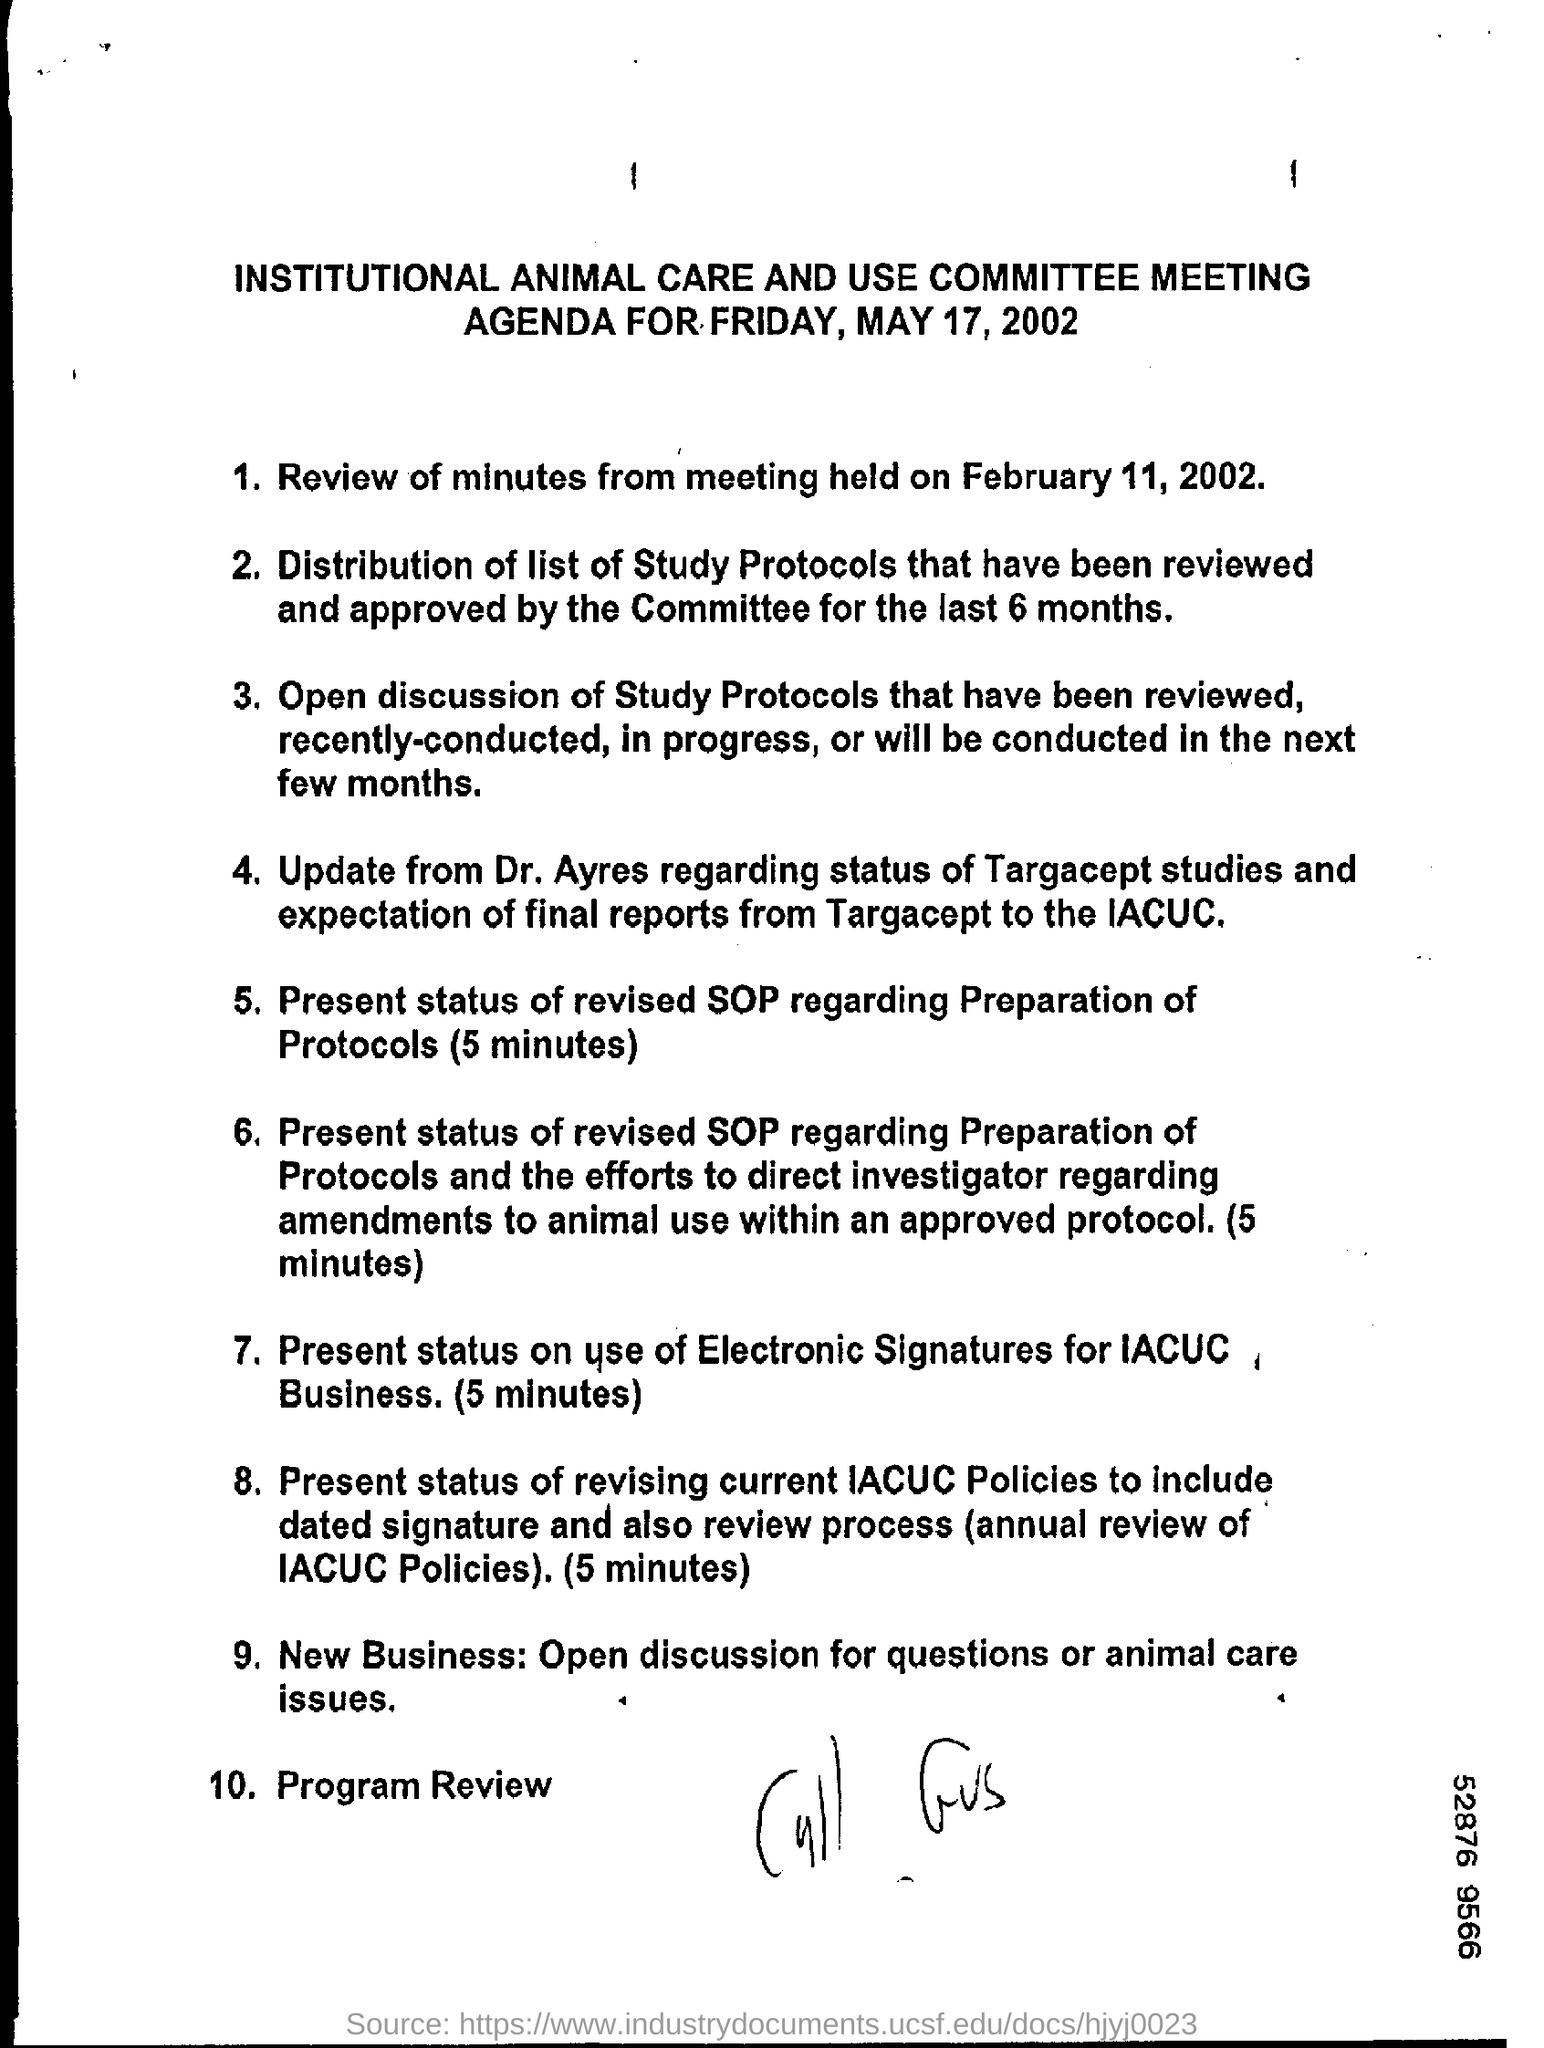What meeting is mentioned?
Your answer should be compact. INSTITUTIONAL ANIMAL CARE AND USE COMMITTEE MEETING. When is the agenda for?
Give a very brief answer. FRIDAY, MAY 17, 2002. Who will update the status of Targacept studies?
Make the answer very short. Dr. Ayres. What is the final point in the agenda?
Provide a succinct answer. Program Review. 